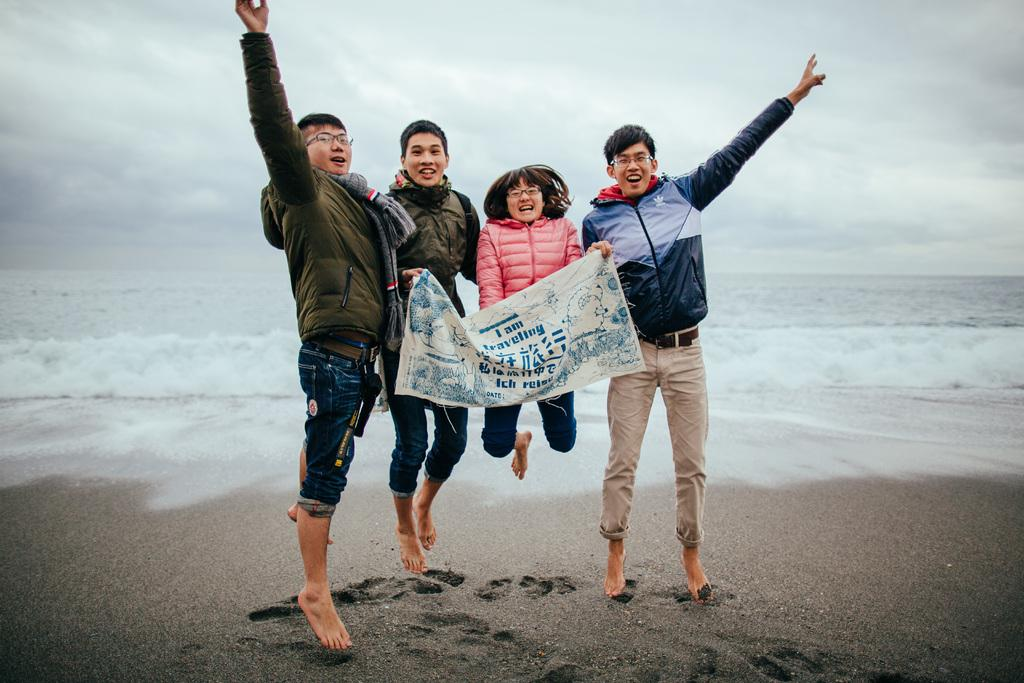How many people are in the foreground of the image? There are four persons in the foreground of the image. What are the persons doing in the image? The persons are in the air and holding a banner. What can be seen in the background of the image? There is sand, water, and clouds in the background of the image. What quarter is the son playing in the image? There is no reference to a son or quarter in the image; it features four persons holding a banner in the air. 